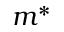<formula> <loc_0><loc_0><loc_500><loc_500>m ^ { * }</formula> 